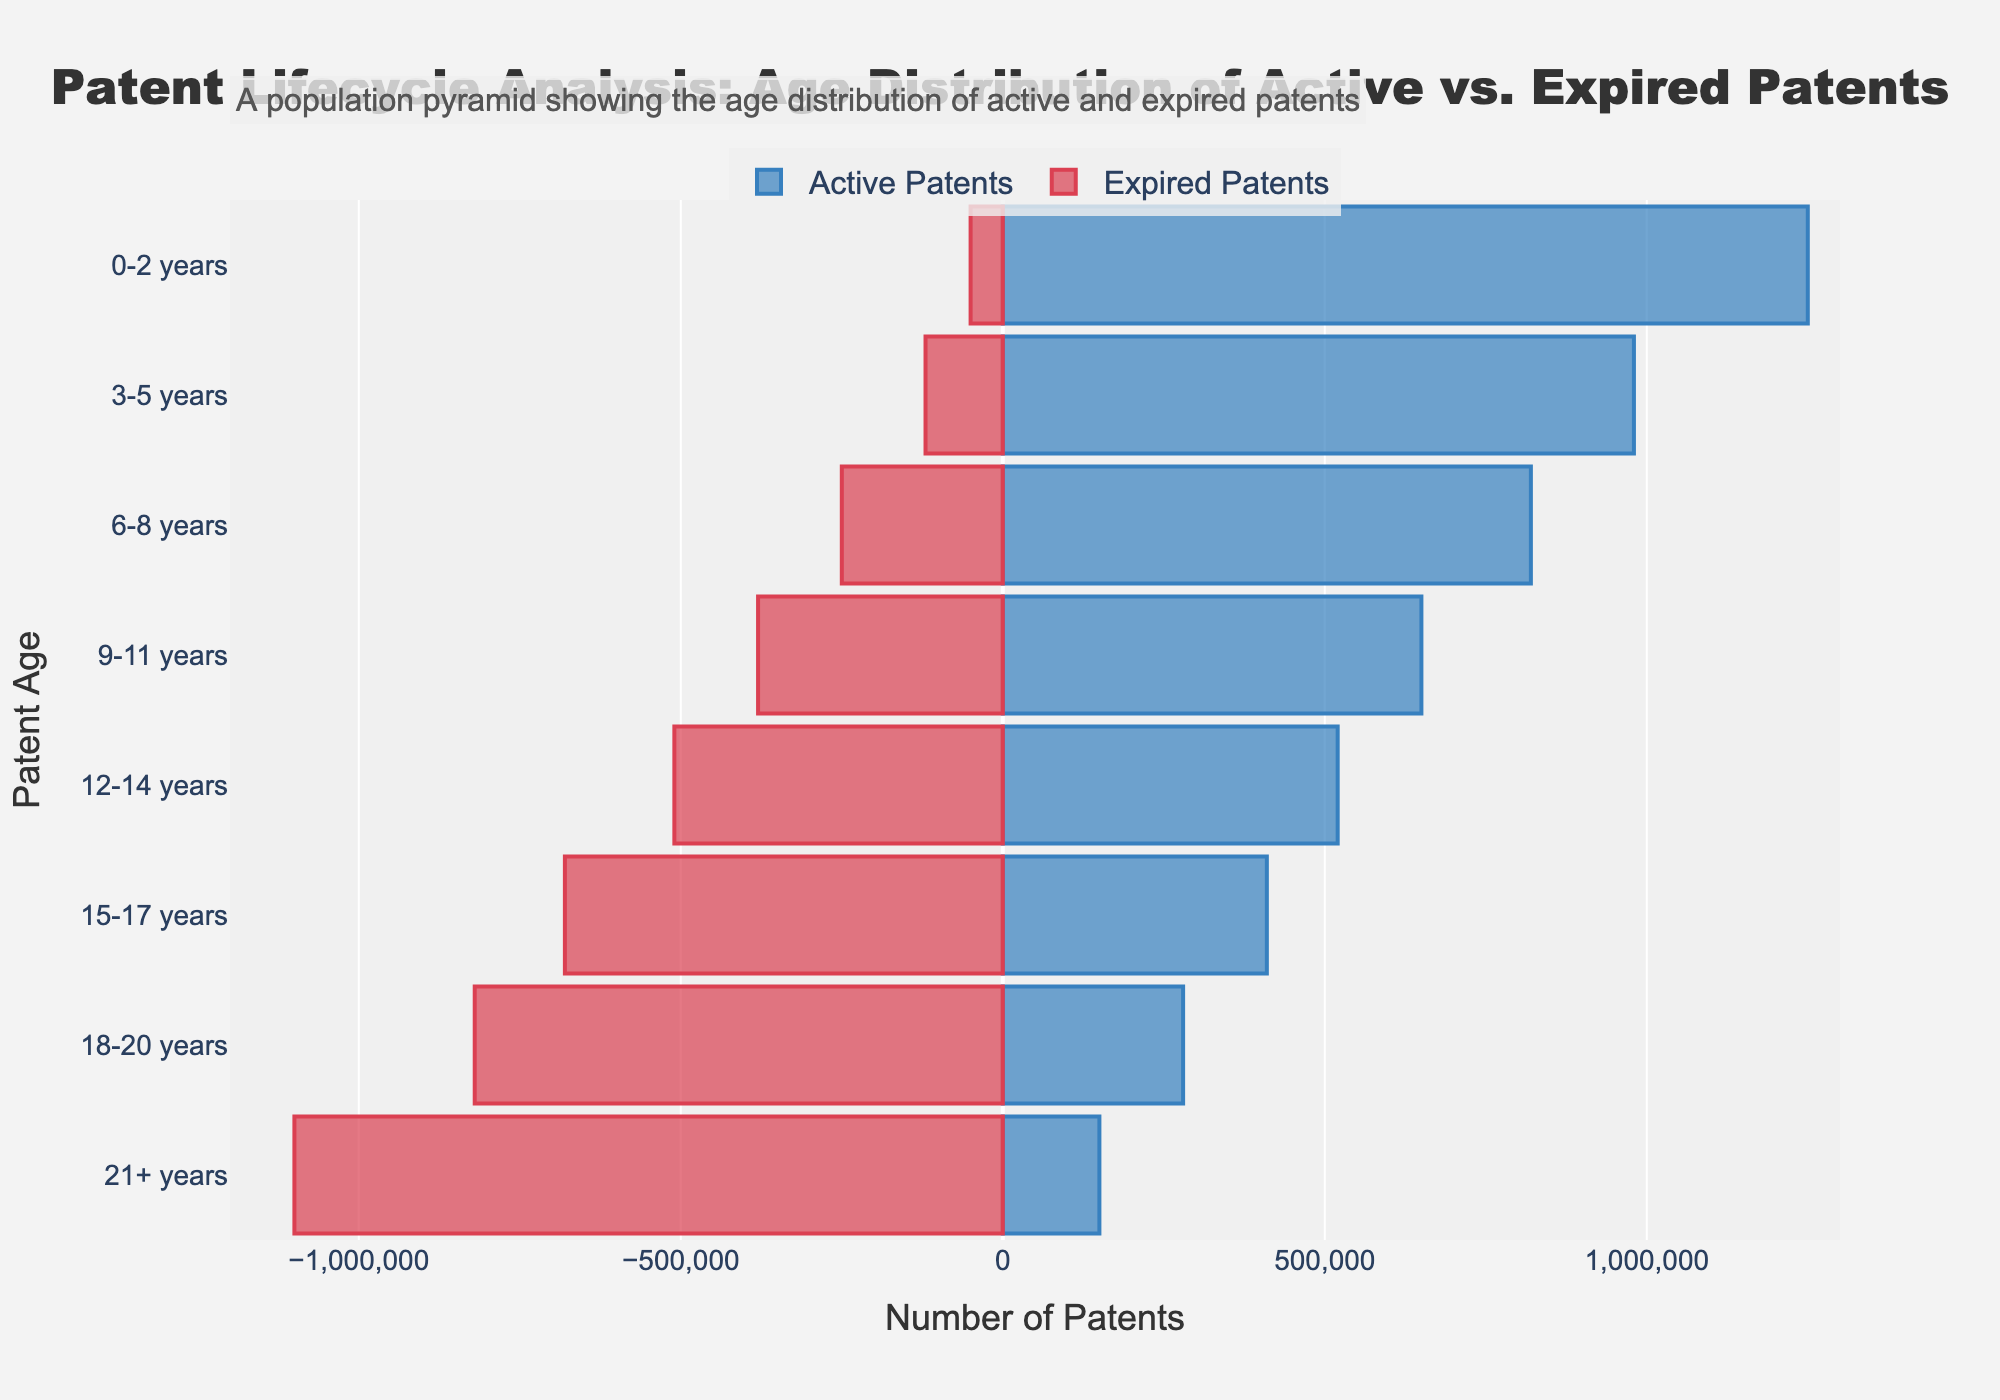what is the title of the plot? The title is present at the top and summarizes the central theme of the graph. It reads "Patent Lifecycle Analysis: Age Distribution of Active vs. Expired Patents".
Answer: Patent Lifecycle Analysis: Age Distribution of Active vs. Expired Patents What is the color of the bars representing Active Patents? Active Patents are represented using blue-colored bars, easily distinguishable from others in the plot.
Answer: Blue What is the age range with the highest number of active patents? By observing the length of the blue bars representing active patents, the age range "0-2 years" has the highest value. This can be immediately seen as the longest bar among the active patents.
Answer: 0-2 years How many expired patents are there for patents aged 15-17 years? To find the number of expired patents that aged 15-17 years, we look at the red bar for that age range which is marked at -680000.
Answer: 680000 Comparing the age range of 9-11 years, are there more active or expired patents? The bars' length in the age range of 9-11 years shows that the blue bar for active patents (650000) is shorter than the red bar for expired patents marked (-380000). Since the value for expired patents is larger when its absolute value is considered, there are more expired patents.
Answer: Expired What is the sum of active and expired patents for the age range of 12-14 years? Adding the number of active patents (520000) and the absolute value of the expired patents (510000) in the age range of 12-14 years gives us 1030000 patents.
Answer: 1030000 Between which age ranges does the number of expired patents increase the most? By comparing the increments of expired patents across age ranges, the biggest increase is from the age range 0-2 years to 3-5 years, jumping from 50000 to 120000, an increase of 70000.
Answer: 0-2 years to 3-5 years In which age range do the active patents drop below the expired patents? Observing the plot, from the age range 15-17 years onwards, the blue bars representing active patents are shorter than the red bars representing expired patents, showing active patents drop noticeably below expired patents from this range.
Answer: 15-17 years What percentage of the total expired patents does the age range 21+ years account for? Sum all expired patents (50000+120000+250000+380000+510000+680000+820000+1100000 = 3885000), the 21+ years is 1100000. The percentage is calculated as (1100000/3885000) * 100 = 28.31%.
Answer: 28.31% Which age group has the smallest difference between active and expired patents? By calculating the difference for each group, the smallest difference is observed for the age group 12-14 years with a difference of 10000 (520000 - 510000).
Answer: 12-14 years 